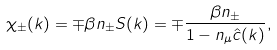Convert formula to latex. <formula><loc_0><loc_0><loc_500><loc_500>\chi _ { \pm } ( k ) = \mp \beta n _ { \pm } S ( k ) = \mp \frac { \beta n _ { \pm } } { 1 - n _ { \mu } \hat { c } ( k ) } ,</formula> 